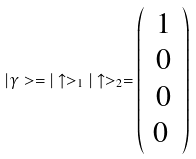<formula> <loc_0><loc_0><loc_500><loc_500>| \gamma > = | \uparrow > _ { 1 } | \uparrow > _ { 2 } = \left ( \begin{array} { c } 1 \\ 0 \\ 0 \\ 0 \ \end{array} \right )</formula> 